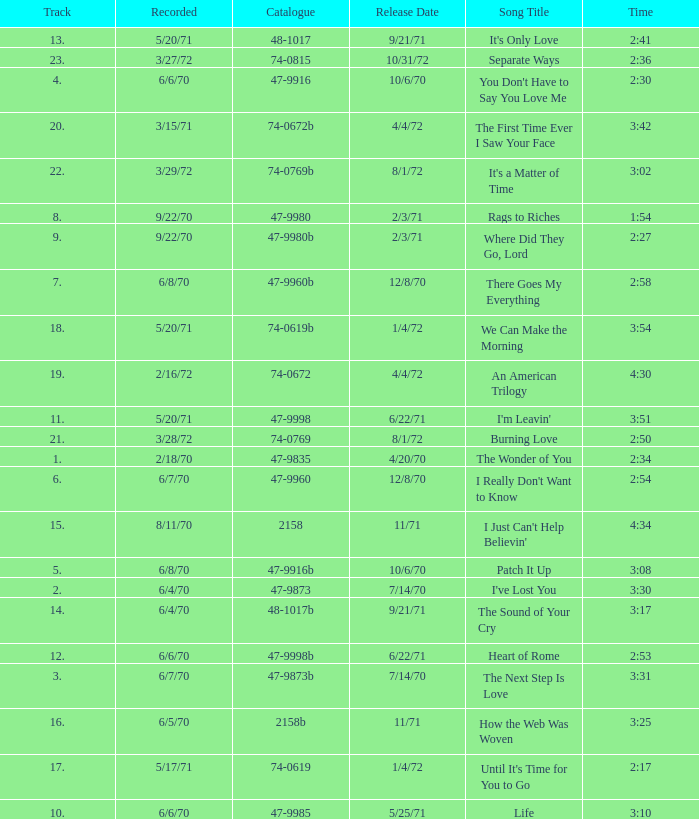Which song was released 12/8/70 with a time of 2:54? I Really Don't Want to Know. 